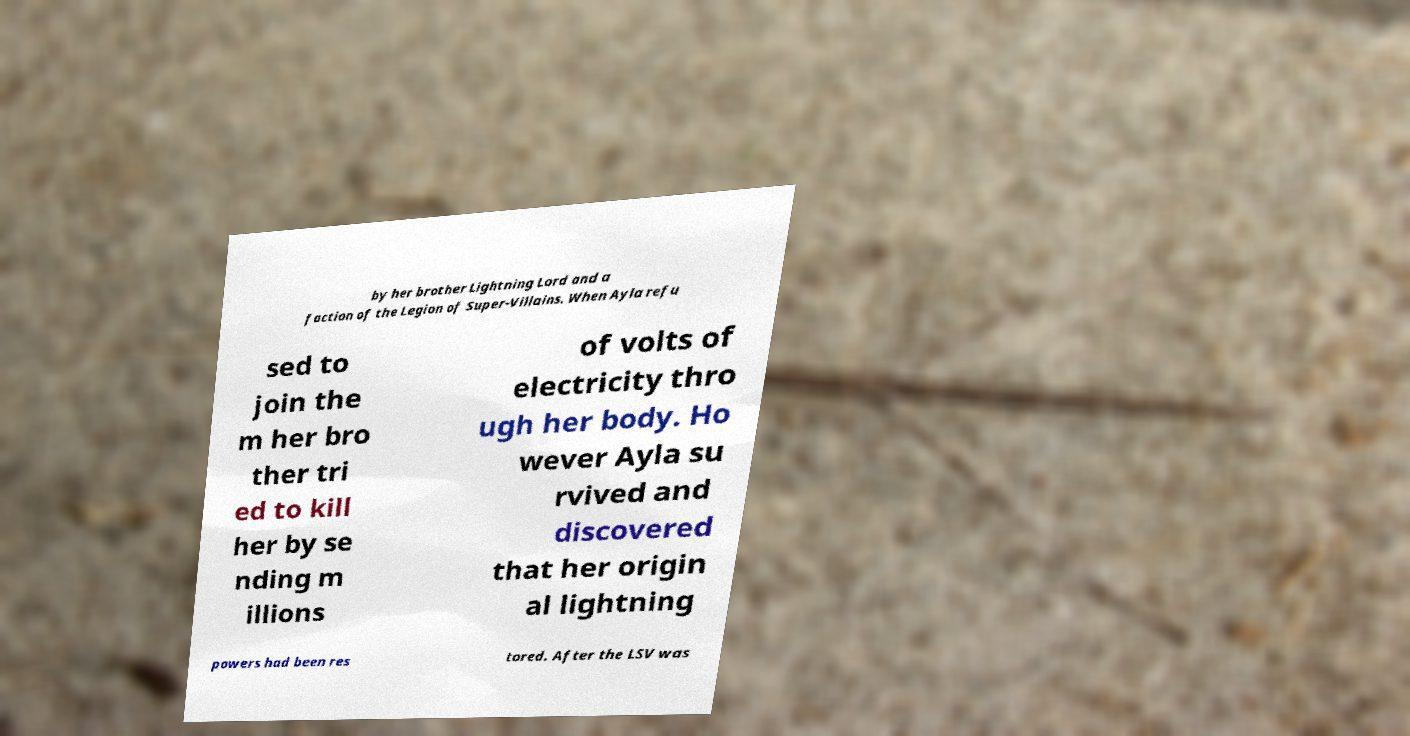Please identify and transcribe the text found in this image. by her brother Lightning Lord and a faction of the Legion of Super-Villains. When Ayla refu sed to join the m her bro ther tri ed to kill her by se nding m illions of volts of electricity thro ugh her body. Ho wever Ayla su rvived and discovered that her origin al lightning powers had been res tored. After the LSV was 